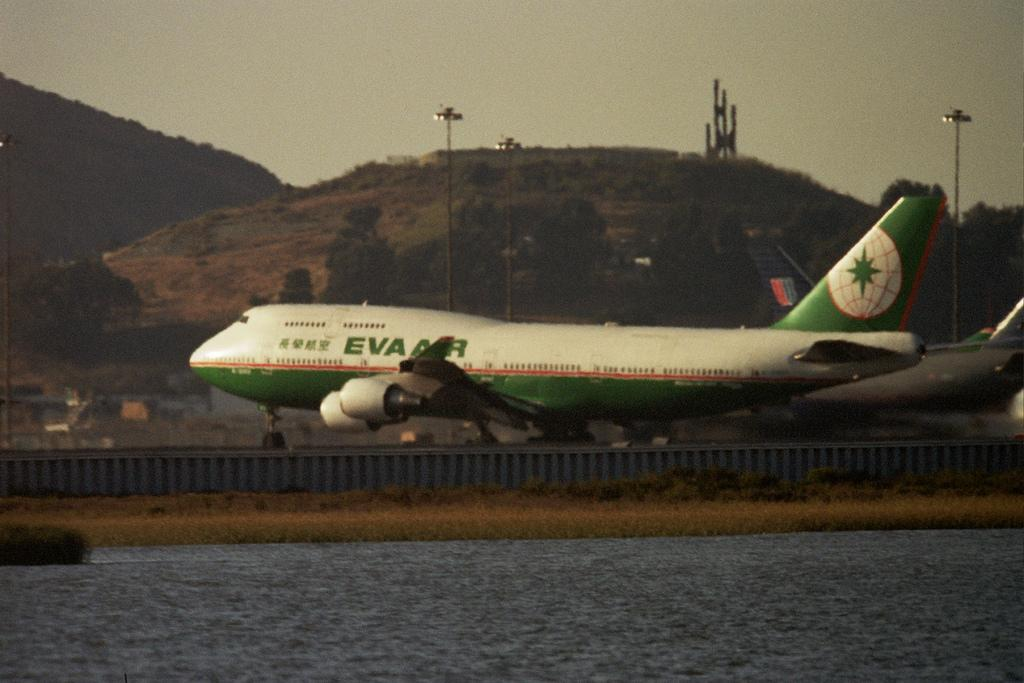Explain the unique identifiers found on the wings of the plane. There is a flag on the side of one of the wings in the image. Refer to the distinct logos or typography found on the plane. The plane has green letters and a green star inside a red circle on its tail. Describe the lighting and visibility conditions in the image. The sky is very hazy, and there is a large light pole with lights on. Briefly describe the landscape around the plane in the image. There is a large body of water, a small bush in the water, a large field of grass, a brown hillside, a fence, and a trail of sand by the water. Explore the relationship between the plane and the fence in the image. The fence acts as a barrier between the plane and the water, and it is a black fence rail extended across the landscape. Where is the plane located in relation to the body of water? The plane is near the water, with a fence between them. What are the distinctive features found on the tail of the plane? A green compass sign and a large black and white globe are present on the tail of the plane. Mention the elements found around the hillside in the image. There is a house at the top of the hill, a small mountain on the side, a large hill behind the plane, and the hillside is brown. Identify the colors present on the plane in the image. The plane is white, green, and red with green letters and a green star inside a red circle on its tail. List the objects related to the airplane's structure in the image. Tail, wings, engines, nose, landing gear wheels, windows, red stripe, flag on the wing, green compass sign, and large black and white globe on the tail. Is the barrier made of bright yellow flowers? The captions mention that the barrier is gray, but no information about it being made of flowers is provided. This instruction is misleading because it suggests the barrier is made of yellow flowers, which is not mentioned in the data. Is the lamp pole in the back of the plane made of glass and emitting purple light? The captions mention a lamp pole with lights near the plane, but no information about its material or the color of the light it emits is provided. The instruction is misleading because it attributes glass material and purple light, which are not mentioned in the data. Does the hillside have a thick layer of snow? The captions state that the hillside is brown, but they do not mention any snow. The instruction is misleading because it suggests an attribute (snow) that is not mentioned in the data. Is the large body of water orange and filled with fish? The captions mention a large body of water and its position, but there is no information about its color or any fish in it. The instruction is misleading because it attributes orange color and fish presence which are not mentioned. Is the window on the plane purple with a green tint? All the given captions about the window on the plane mention only its position and size, but not its color. The instruction is misleading because it attributes colors that are not mentioned in the data. Are the letters on the side of the plane red and blue? The captions state that there are large green letters on the side of the plane. The instruction is misleading because it suggests different colors for the letters. 